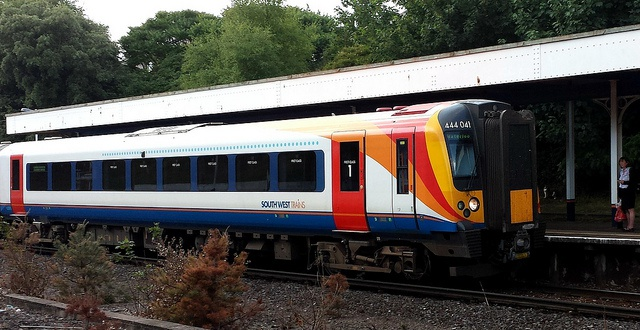Describe the objects in this image and their specific colors. I can see train in gray, black, white, navy, and brown tones, people in gray, black, and maroon tones, and handbag in gray, maroon, black, and brown tones in this image. 